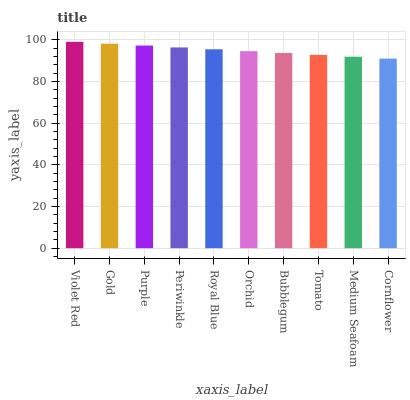Is Cornflower the minimum?
Answer yes or no. Yes. Is Violet Red the maximum?
Answer yes or no. Yes. Is Gold the minimum?
Answer yes or no. No. Is Gold the maximum?
Answer yes or no. No. Is Violet Red greater than Gold?
Answer yes or no. Yes. Is Gold less than Violet Red?
Answer yes or no. Yes. Is Gold greater than Violet Red?
Answer yes or no. No. Is Violet Red less than Gold?
Answer yes or no. No. Is Royal Blue the high median?
Answer yes or no. Yes. Is Orchid the low median?
Answer yes or no. Yes. Is Tomato the high median?
Answer yes or no. No. Is Tomato the low median?
Answer yes or no. No. 